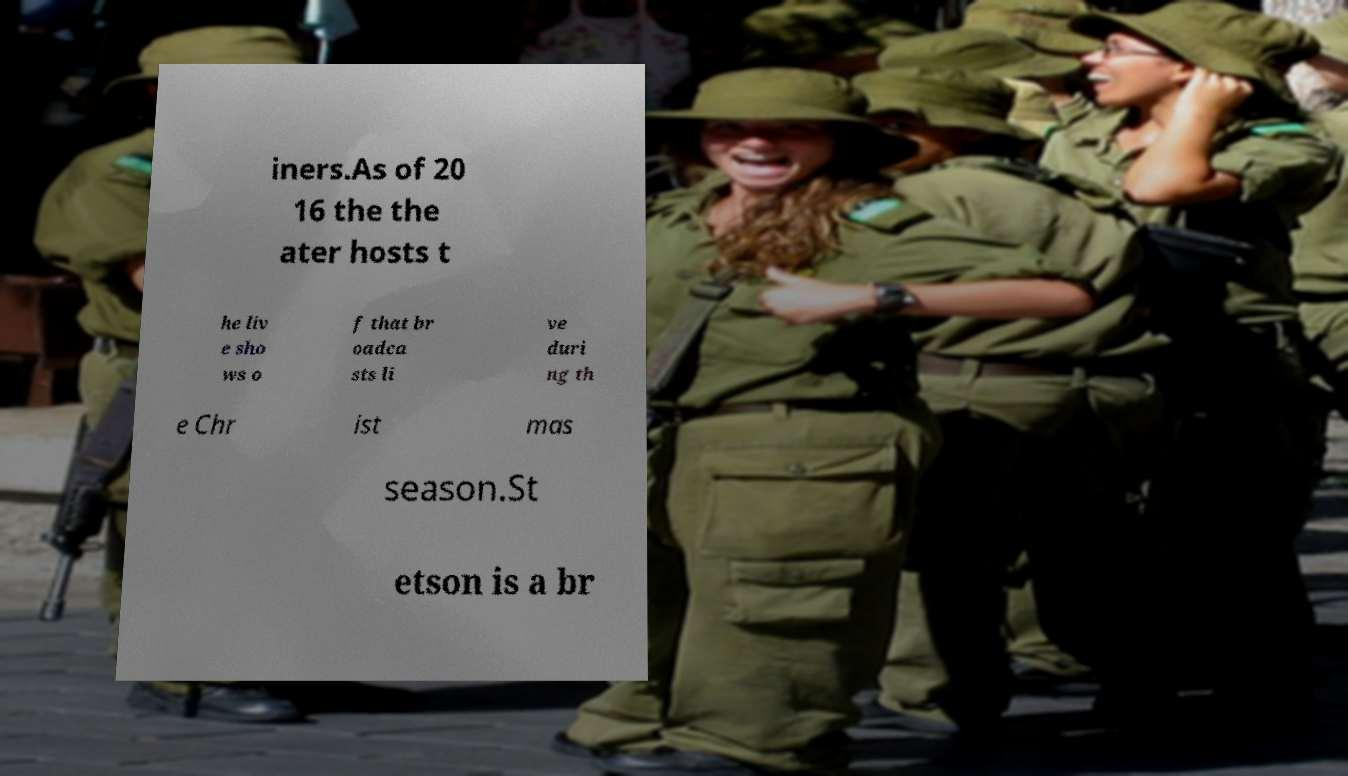I need the written content from this picture converted into text. Can you do that? iners.As of 20 16 the the ater hosts t he liv e sho ws o f that br oadca sts li ve duri ng th e Chr ist mas season.St etson is a br 